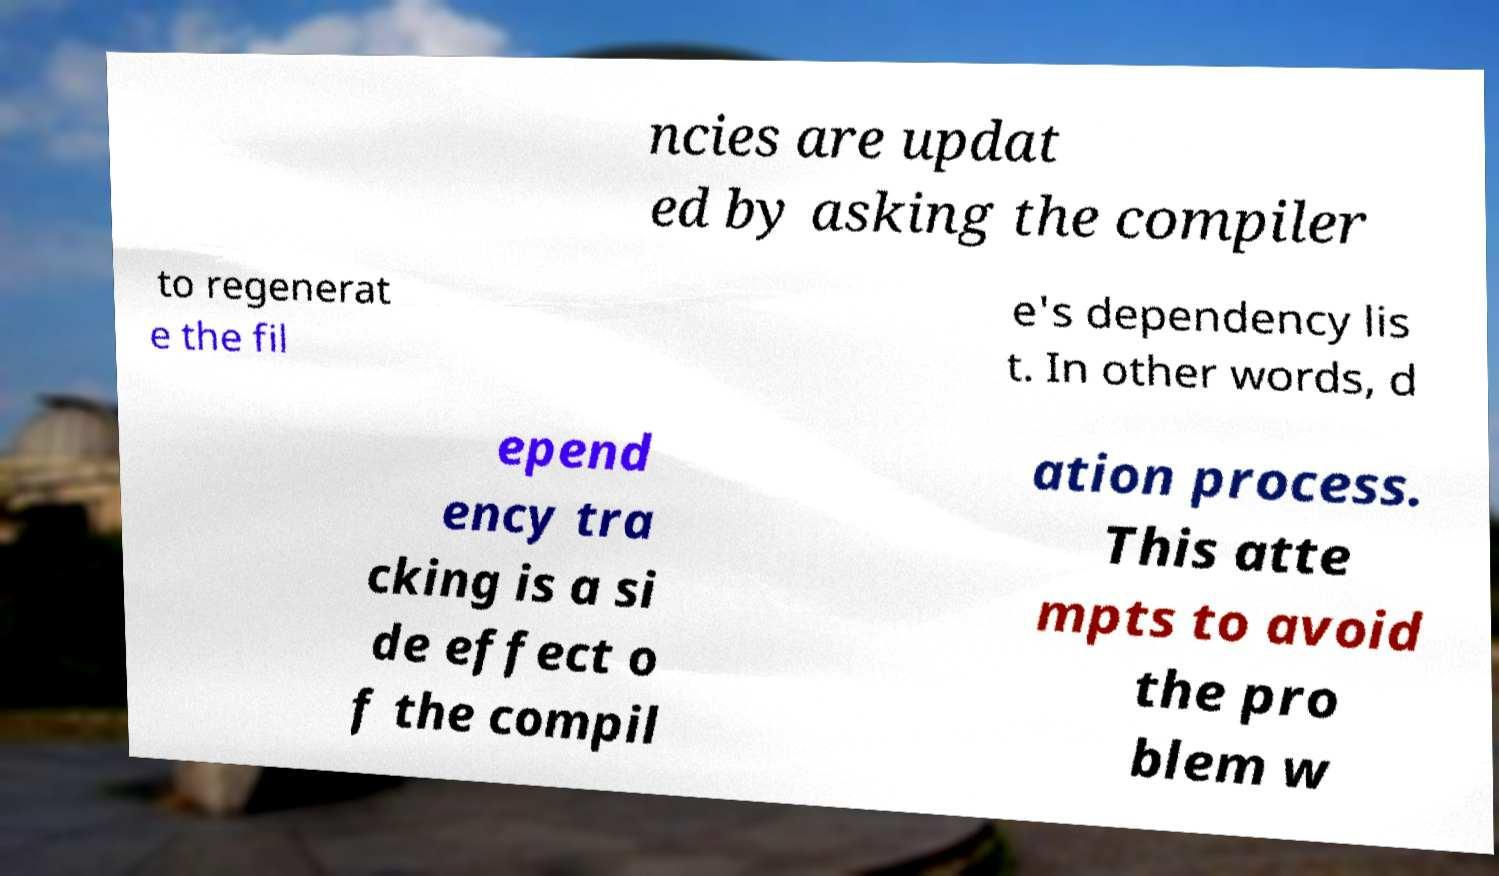What messages or text are displayed in this image? I need them in a readable, typed format. ncies are updat ed by asking the compiler to regenerat e the fil e's dependency lis t. In other words, d epend ency tra cking is a si de effect o f the compil ation process. This atte mpts to avoid the pro blem w 